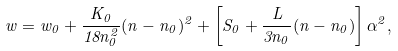Convert formula to latex. <formula><loc_0><loc_0><loc_500><loc_500>w = w _ { 0 } + \frac { K _ { 0 } } { 1 8 n _ { 0 } ^ { 2 } } ( n - n _ { 0 } ) ^ { 2 } + \left [ S _ { 0 } + \frac { L } { 3 n _ { 0 } } ( n - n _ { 0 } ) \right ] \alpha ^ { 2 } ,</formula> 